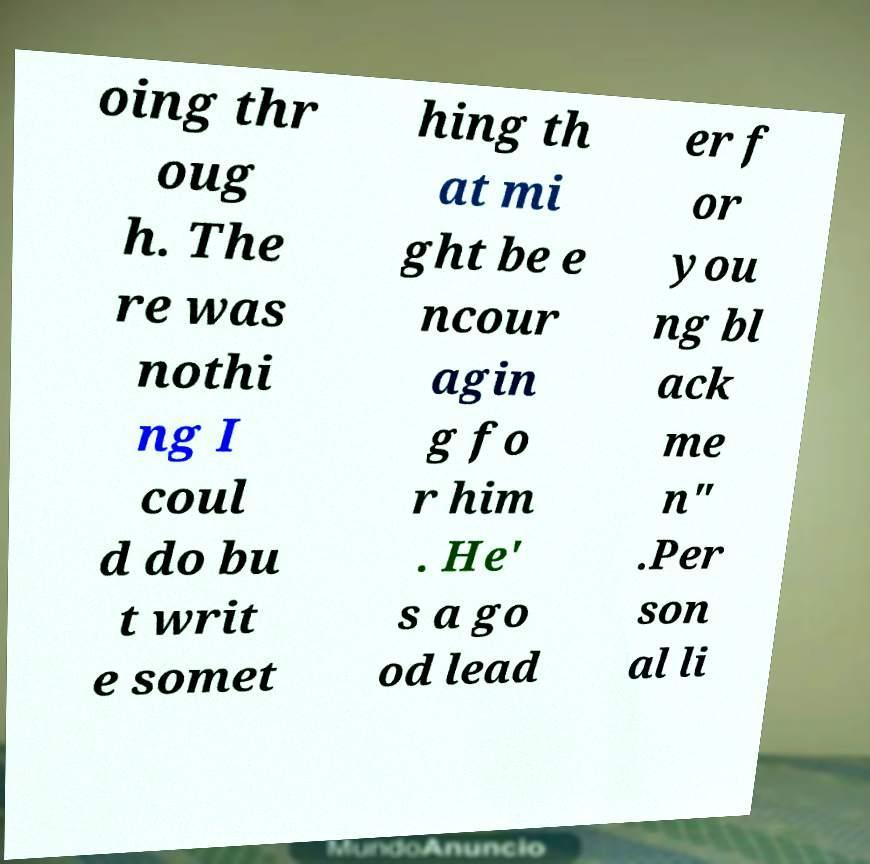Can you accurately transcribe the text from the provided image for me? oing thr oug h. The re was nothi ng I coul d do bu t writ e somet hing th at mi ght be e ncour agin g fo r him . He' s a go od lead er f or you ng bl ack me n" .Per son al li 